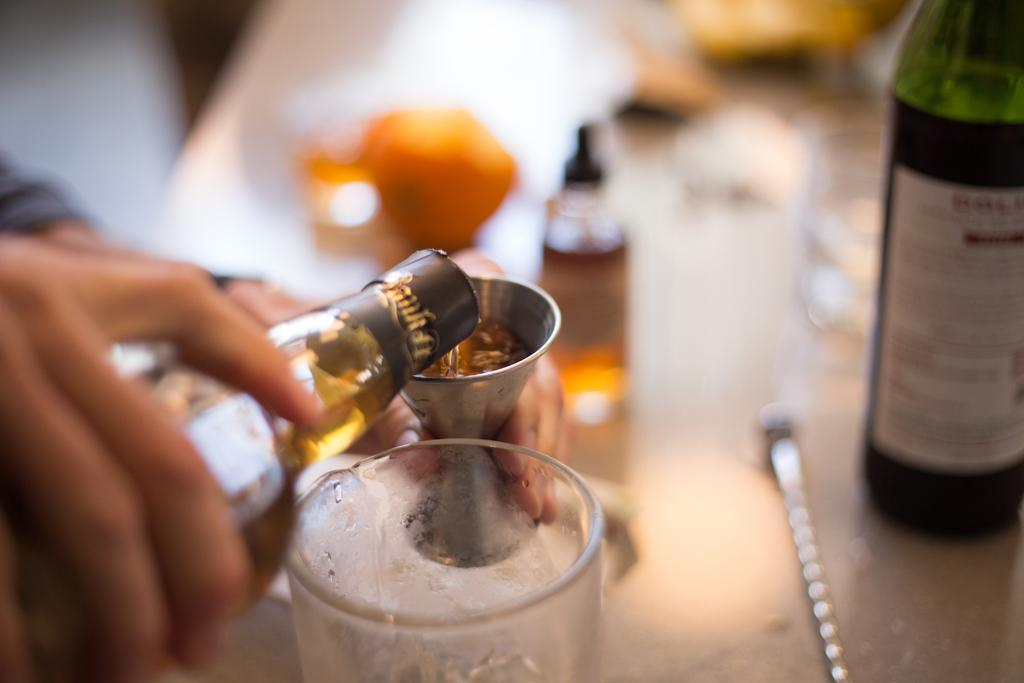What is being held by the hands in the image? There are glasses and bottles in the image that are being held by hands. What type of objects are present in the image besides the glasses and bottles? The background of the image is blurred, so it is difficult to identify any other objects. What type of copper material is being used for the hobbies in the image? There is no copper material or hobbies present in the image; it only features hands holding glasses and bottles. 